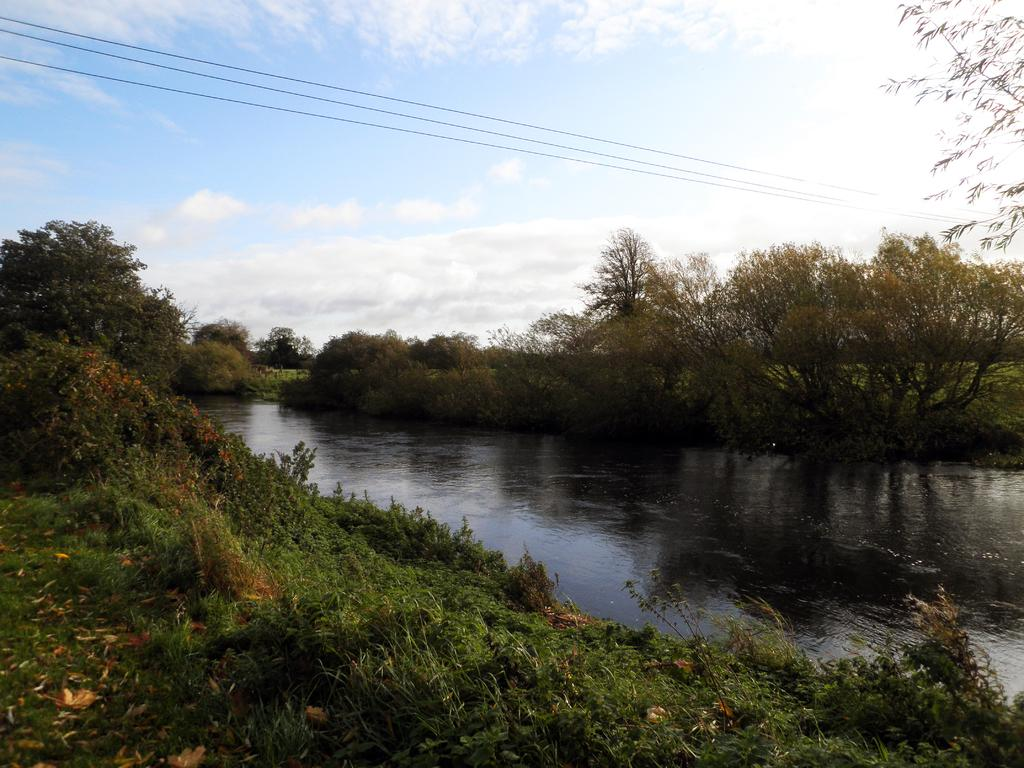What is the primary element visible in the image? There is water in the image. What other natural elements can be seen in the image? There are trees in the image. Are there any man-made structures visible? Yes, there are wires in the image. What can be seen in the background of the image? The sky is visible in the background of the image, and clouds are present in the sky. What type of fan can be seen in the image? There is no fan present in the image. 